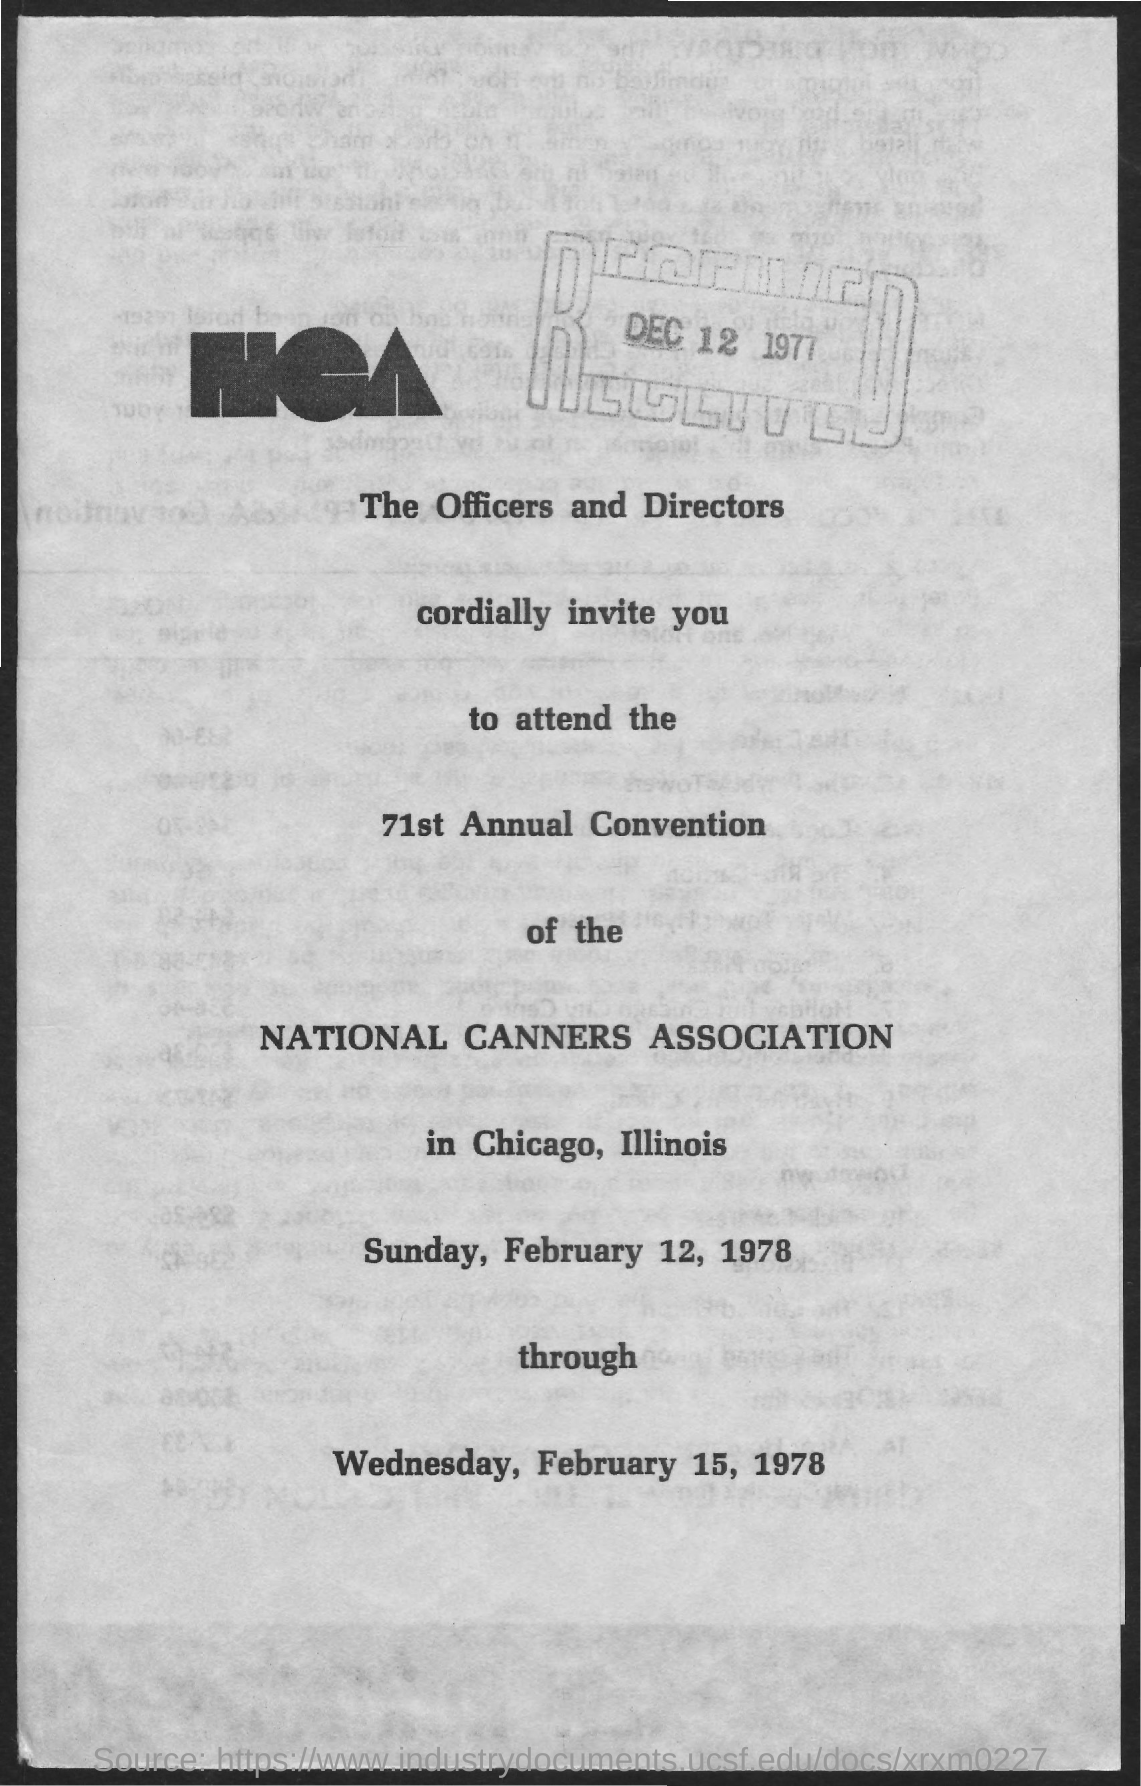List a handful of essential elements in this visual. The National Canners Association's annual convention is mentioned. The annual convention will take place on Sunday, February 12, 1978 and will end on Wednesday, February 15, 1978. The document was received on December 12, 1977. The convention will take place in Chicago, Illinois. 